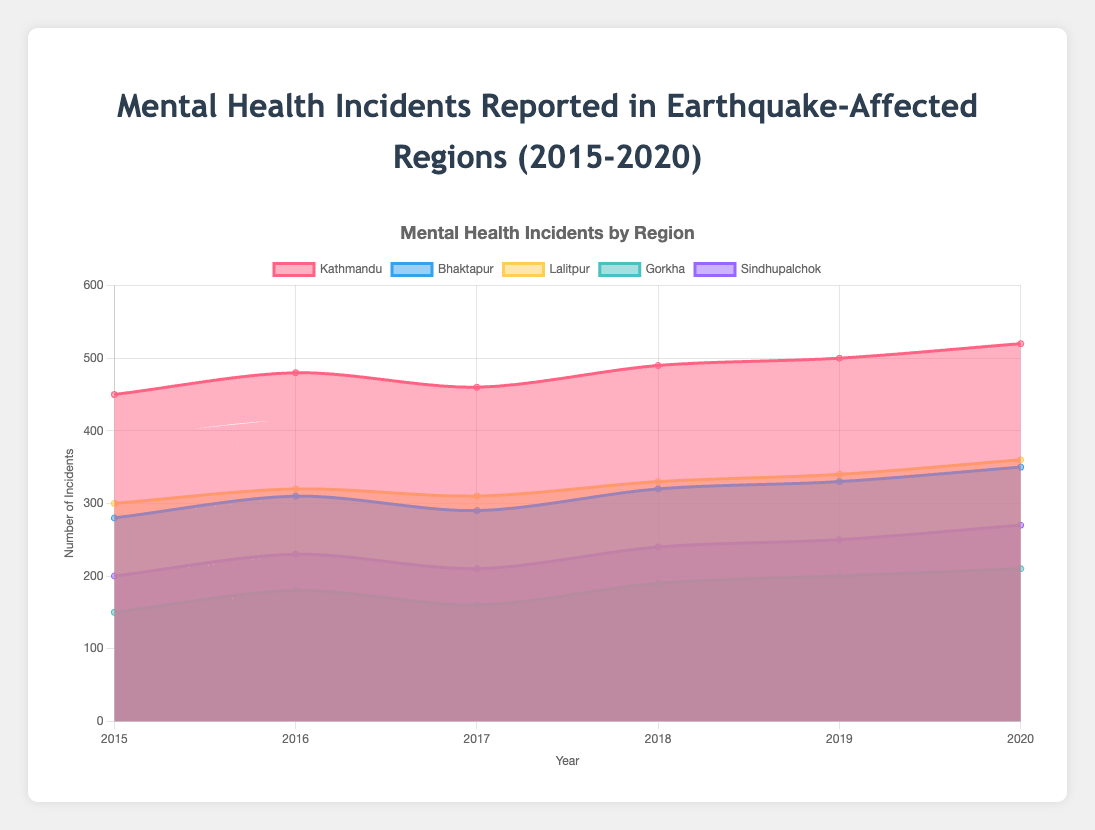What is the title of the chart? The title is displayed at the top and reads "Mental Health Incidents Reported in Earthquake-Affected Regions (2015-2020)".
Answer: Mental Health Incidents Reported in Earthquake-Affected Regions (2015-2020) How many years of data are shown in the chart? The x-axis lists the years, which are 2015, 2016, 2017, 2018, 2019, and 2020. Counting them gives 6 years.
Answer: 6 Which region reported the highest number of mental health incidents in 2019? By examining the data points for 2019, we see that Kathmandu has the highest value with 500 incidents.
Answer: Kathmandu In which year did Bhaktapur see the highest number of mental health incidents? By looking at Bhaktapur’s data points, the highest number (350) appears in 2020.
Answer: 2020 What is the difference in the number of mental health incidents between Gorkha and Lalitpur in 2015? Gorkha reported 150 incidents in 2015 while Lalitpur reported 300 incidents. The difference is 300 - 150.
Answer: 150 What is the total number of mental health incidents reported across all regions in 2017? Summing the incidents from each region for 2017: Kathmandu (460) + Bhaktapur (290) + Lalitpur (310) + Gorkha (160) + Sindhupalchok (210) = 1430.
Answer: 1430 Which region shows the most consistent trend in mental health incidents during the period 2015-2020? The line representing Bhaktapur shows a consistent upward trend without major fluctuations.
Answer: Bhaktapur How did the number of mental health incidents in Sindhupalchok change from 2015 to 2020? Sindhupalchok started with 200 incidents in 2015 and increased gradually to 270 incidents by 2020.
Answer: Increased by 70 On average, how many mental health incidents were reported per year in Lalitpur between 2015 and 2020? The total number of incidents over these years is 300 + 320 + 310 + 330 + 340 + 360 = 1960. Dividing by 6 gives an average: 1960 / 6 = 326.67.
Answer: 326.67 